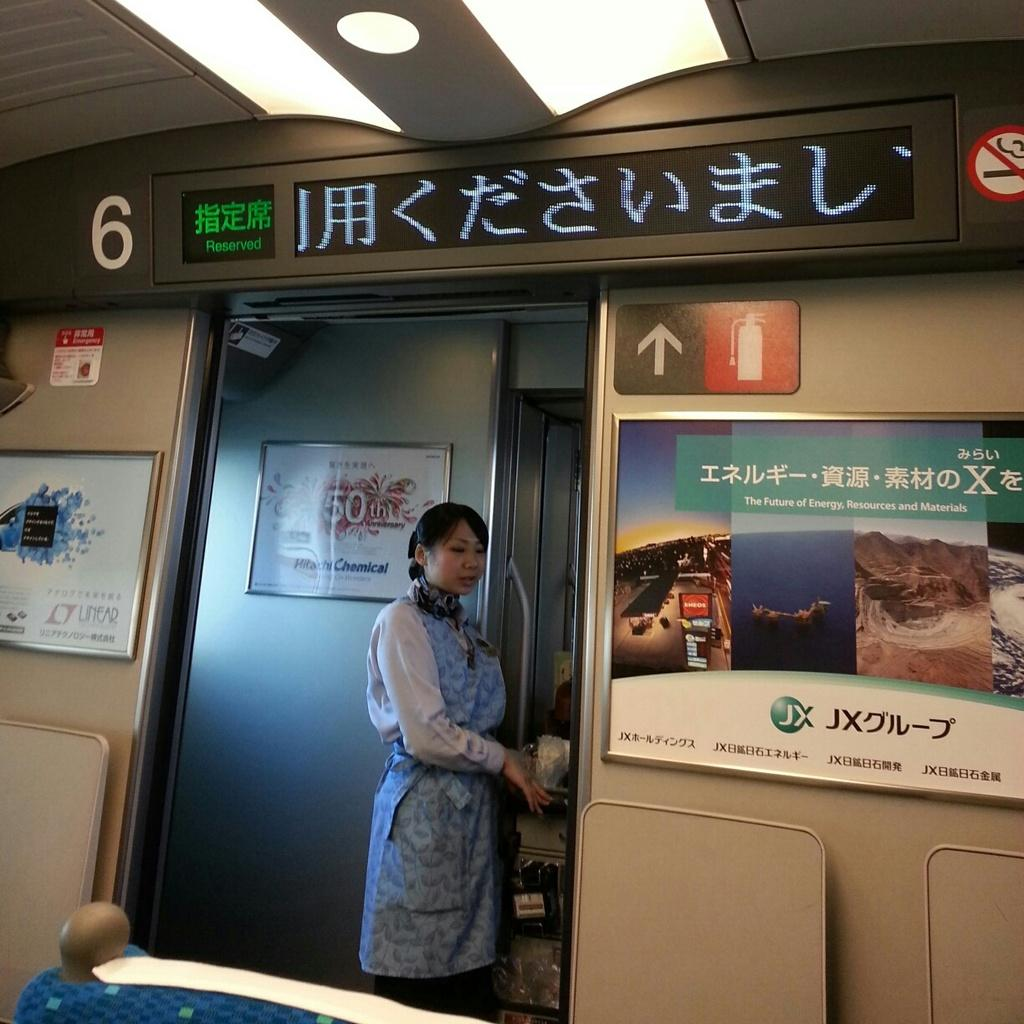What is the main subject of the image? There is a person standing in the image. Can you describe the person's appearance? The person is wearing clothes. What objects are present on the sides of the image? There are boards on both the left and right sides of the image. What can be seen at the top of the image? There is a light at the top of the image. What type of cup is being used for the operation in the image? There is no cup or operation present in the image; it features a person standing with boards on both sides and a light at the top. 